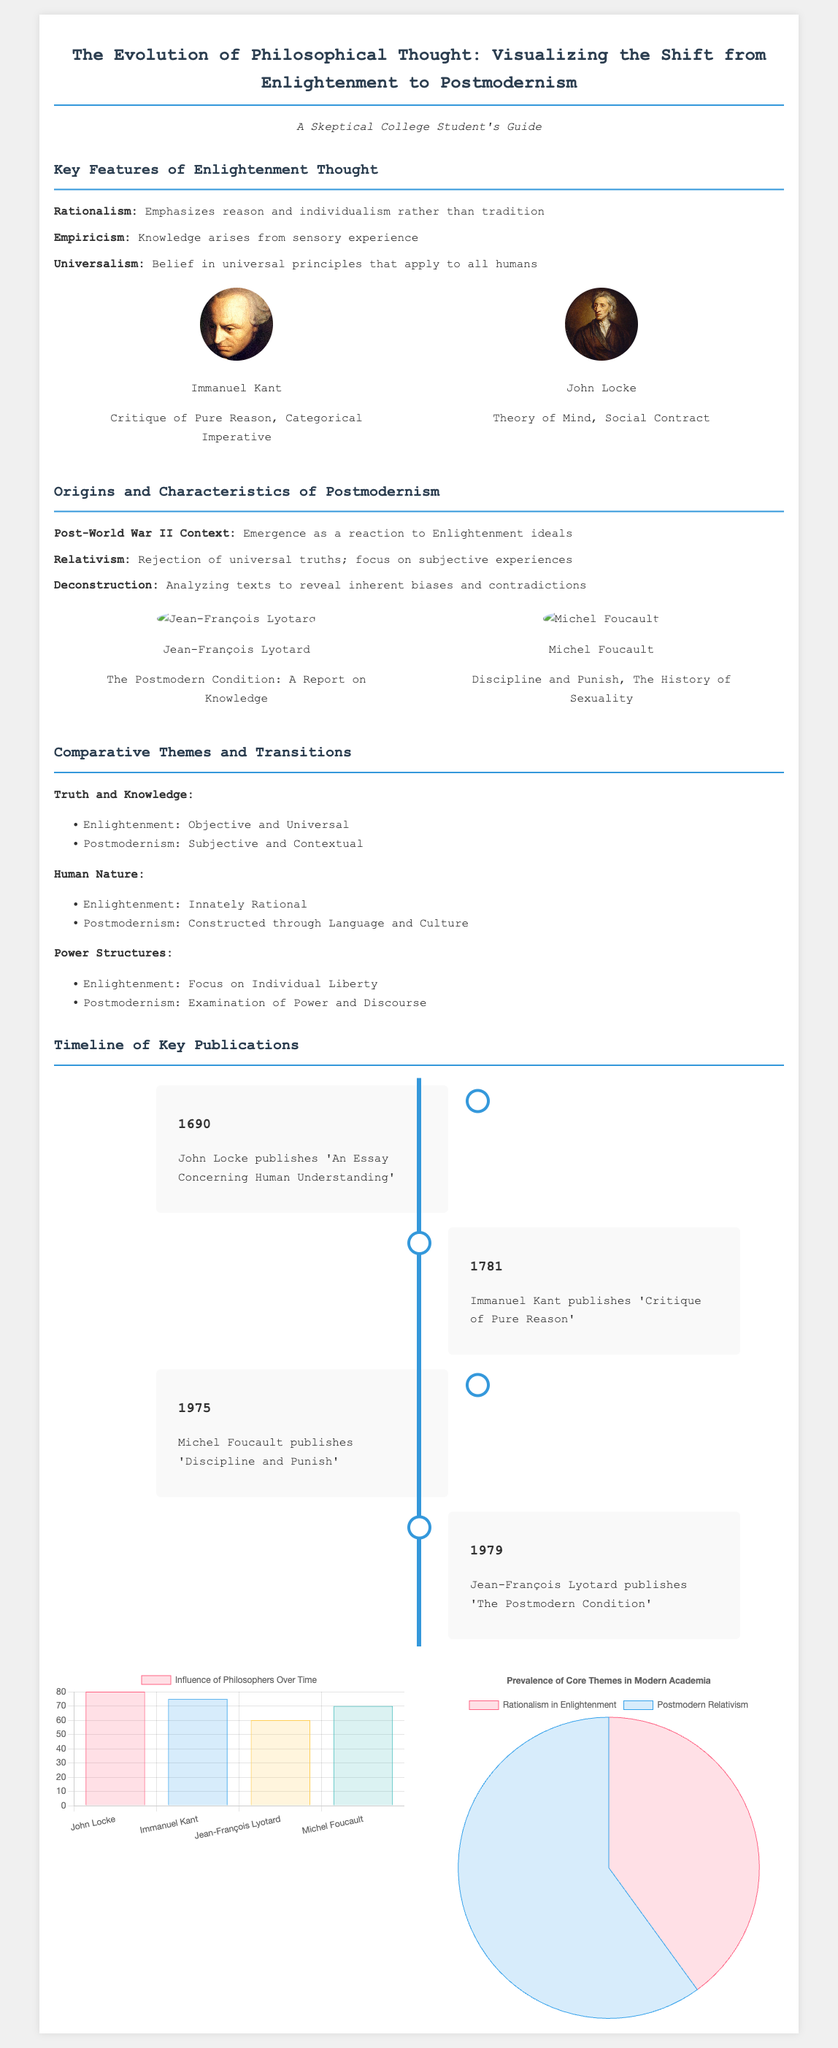what are the three key features of Enlightenment thought? The key features listed in the document are Rationalism, Empiricism, and Universalism.
Answer: Rationalism, Empiricism, Universalism who published 'Critique of Pure Reason'? This title is attributed to Immanuel Kant, as mentioned in the timeline.
Answer: Immanuel Kant what year was 'The Postmodern Condition' published? The document states that Jean-François Lyotard published this work in 1979.
Answer: 1979 what is the initial percentage of Rationalism in the Modern Academia pie chart? The pie chart shows that Rationalism accounts for 40% of the core themes in modern academia.
Answer: 40 which philosopher is associated with the theory of Social Contract? John Locke is noted for his contributions to the theory of Social Contract.
Answer: John Locke how does Enlightenment view human nature? According to the comparative themes, Enlightenment views human nature as Innately Rational.
Answer: Innately Rational what is the significance of the year 1690 in the timeline? John Locke published 'An Essay Concerning Human Understanding' in that year.
Answer: 1690 which philosopher emphasized the examination of power and discourse? The document indicates that Michel Foucault focuses on this examination.
Answer: Michel Foucault 